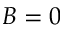<formula> <loc_0><loc_0><loc_500><loc_500>B = 0</formula> 